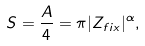<formula> <loc_0><loc_0><loc_500><loc_500>S = { \frac { A } { 4 } } = \pi | Z _ { f i x } | ^ { \alpha } ,</formula> 